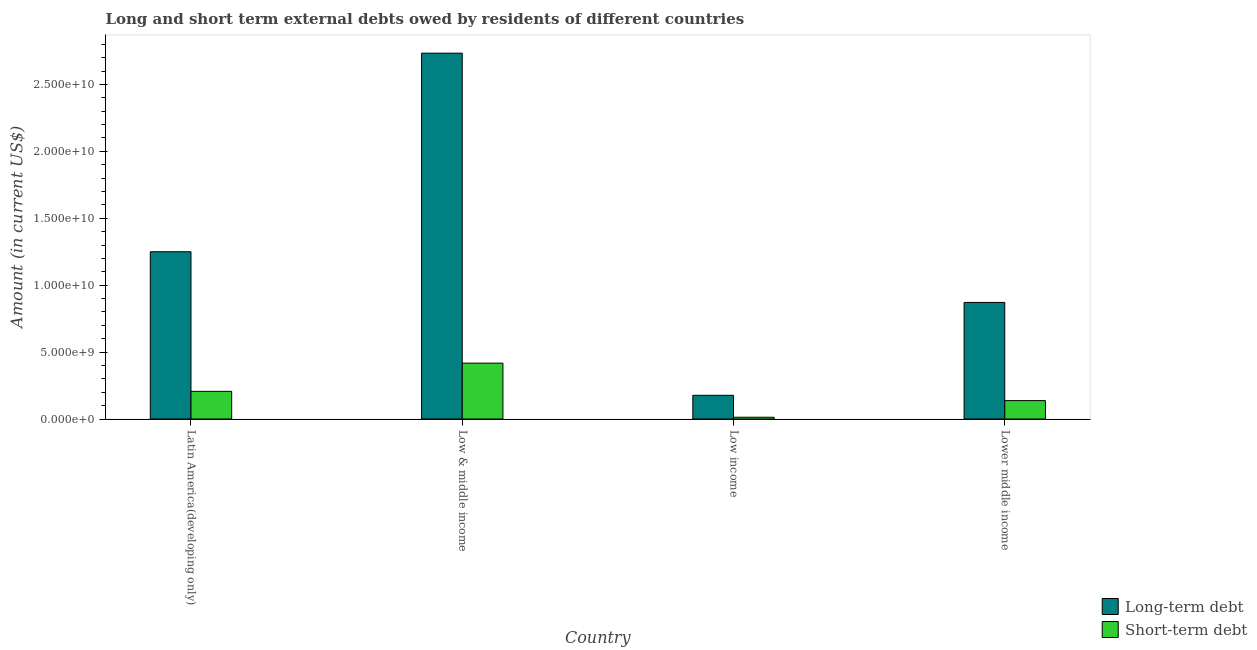How many different coloured bars are there?
Keep it short and to the point. 2. Are the number of bars per tick equal to the number of legend labels?
Make the answer very short. Yes. How many bars are there on the 3rd tick from the left?
Your response must be concise. 2. How many bars are there on the 3rd tick from the right?
Your answer should be very brief. 2. What is the label of the 2nd group of bars from the left?
Keep it short and to the point. Low & middle income. What is the short-term debts owed by residents in Lower middle income?
Offer a very short reply. 1.37e+09. Across all countries, what is the maximum long-term debts owed by residents?
Provide a short and direct response. 2.73e+1. Across all countries, what is the minimum short-term debts owed by residents?
Offer a very short reply. 1.32e+08. In which country was the long-term debts owed by residents maximum?
Make the answer very short. Low & middle income. In which country was the long-term debts owed by residents minimum?
Your response must be concise. Low income. What is the total short-term debts owed by residents in the graph?
Give a very brief answer. 7.75e+09. What is the difference between the long-term debts owed by residents in Latin America(developing only) and that in Lower middle income?
Provide a succinct answer. 3.79e+09. What is the difference between the short-term debts owed by residents in Lower middle income and the long-term debts owed by residents in Low income?
Your answer should be compact. -3.97e+08. What is the average long-term debts owed by residents per country?
Provide a short and direct response. 1.26e+1. What is the difference between the long-term debts owed by residents and short-term debts owed by residents in Lower middle income?
Make the answer very short. 7.34e+09. What is the ratio of the long-term debts owed by residents in Latin America(developing only) to that in Low income?
Offer a very short reply. 7.06. Is the difference between the short-term debts owed by residents in Low & middle income and Lower middle income greater than the difference between the long-term debts owed by residents in Low & middle income and Lower middle income?
Ensure brevity in your answer.  No. What is the difference between the highest and the second highest long-term debts owed by residents?
Give a very brief answer. 1.48e+1. What is the difference between the highest and the lowest short-term debts owed by residents?
Provide a short and direct response. 4.04e+09. What does the 1st bar from the left in Low income represents?
Your response must be concise. Long-term debt. What does the 1st bar from the right in Low income represents?
Make the answer very short. Short-term debt. How many bars are there?
Your response must be concise. 8. Are all the bars in the graph horizontal?
Offer a terse response. No. What is the difference between two consecutive major ticks on the Y-axis?
Your answer should be very brief. 5.00e+09. Are the values on the major ticks of Y-axis written in scientific E-notation?
Offer a terse response. Yes. Does the graph contain grids?
Offer a very short reply. No. Where does the legend appear in the graph?
Your response must be concise. Bottom right. How many legend labels are there?
Offer a terse response. 2. What is the title of the graph?
Give a very brief answer. Long and short term external debts owed by residents of different countries. What is the label or title of the Y-axis?
Offer a very short reply. Amount (in current US$). What is the Amount (in current US$) of Long-term debt in Latin America(developing only)?
Give a very brief answer. 1.25e+1. What is the Amount (in current US$) of Short-term debt in Latin America(developing only)?
Provide a succinct answer. 2.07e+09. What is the Amount (in current US$) in Long-term debt in Low & middle income?
Your answer should be very brief. 2.73e+1. What is the Amount (in current US$) of Short-term debt in Low & middle income?
Offer a very short reply. 4.18e+09. What is the Amount (in current US$) of Long-term debt in Low income?
Offer a very short reply. 1.77e+09. What is the Amount (in current US$) of Short-term debt in Low income?
Your answer should be compact. 1.32e+08. What is the Amount (in current US$) in Long-term debt in Lower middle income?
Give a very brief answer. 8.71e+09. What is the Amount (in current US$) in Short-term debt in Lower middle income?
Offer a terse response. 1.37e+09. Across all countries, what is the maximum Amount (in current US$) in Long-term debt?
Your response must be concise. 2.73e+1. Across all countries, what is the maximum Amount (in current US$) in Short-term debt?
Offer a terse response. 4.18e+09. Across all countries, what is the minimum Amount (in current US$) of Long-term debt?
Provide a succinct answer. 1.77e+09. Across all countries, what is the minimum Amount (in current US$) in Short-term debt?
Offer a very short reply. 1.32e+08. What is the total Amount (in current US$) of Long-term debt in the graph?
Keep it short and to the point. 5.03e+1. What is the total Amount (in current US$) in Short-term debt in the graph?
Make the answer very short. 7.75e+09. What is the difference between the Amount (in current US$) of Long-term debt in Latin America(developing only) and that in Low & middle income?
Offer a very short reply. -1.48e+1. What is the difference between the Amount (in current US$) of Short-term debt in Latin America(developing only) and that in Low & middle income?
Your answer should be very brief. -2.11e+09. What is the difference between the Amount (in current US$) in Long-term debt in Latin America(developing only) and that in Low income?
Offer a very short reply. 1.07e+1. What is the difference between the Amount (in current US$) of Short-term debt in Latin America(developing only) and that in Low income?
Your response must be concise. 1.94e+09. What is the difference between the Amount (in current US$) of Long-term debt in Latin America(developing only) and that in Lower middle income?
Your answer should be compact. 3.79e+09. What is the difference between the Amount (in current US$) of Short-term debt in Latin America(developing only) and that in Lower middle income?
Ensure brevity in your answer.  6.94e+08. What is the difference between the Amount (in current US$) in Long-term debt in Low & middle income and that in Low income?
Offer a terse response. 2.56e+1. What is the difference between the Amount (in current US$) in Short-term debt in Low & middle income and that in Low income?
Make the answer very short. 4.04e+09. What is the difference between the Amount (in current US$) in Long-term debt in Low & middle income and that in Lower middle income?
Ensure brevity in your answer.  1.86e+1. What is the difference between the Amount (in current US$) in Short-term debt in Low & middle income and that in Lower middle income?
Offer a very short reply. 2.80e+09. What is the difference between the Amount (in current US$) of Long-term debt in Low income and that in Lower middle income?
Offer a very short reply. -6.94e+09. What is the difference between the Amount (in current US$) of Short-term debt in Low income and that in Lower middle income?
Provide a short and direct response. -1.24e+09. What is the difference between the Amount (in current US$) in Long-term debt in Latin America(developing only) and the Amount (in current US$) in Short-term debt in Low & middle income?
Offer a terse response. 8.32e+09. What is the difference between the Amount (in current US$) in Long-term debt in Latin America(developing only) and the Amount (in current US$) in Short-term debt in Low income?
Your answer should be very brief. 1.24e+1. What is the difference between the Amount (in current US$) of Long-term debt in Latin America(developing only) and the Amount (in current US$) of Short-term debt in Lower middle income?
Make the answer very short. 1.11e+1. What is the difference between the Amount (in current US$) in Long-term debt in Low & middle income and the Amount (in current US$) in Short-term debt in Low income?
Ensure brevity in your answer.  2.72e+1. What is the difference between the Amount (in current US$) of Long-term debt in Low & middle income and the Amount (in current US$) of Short-term debt in Lower middle income?
Make the answer very short. 2.60e+1. What is the difference between the Amount (in current US$) in Long-term debt in Low income and the Amount (in current US$) in Short-term debt in Lower middle income?
Make the answer very short. 3.97e+08. What is the average Amount (in current US$) in Long-term debt per country?
Keep it short and to the point. 1.26e+1. What is the average Amount (in current US$) of Short-term debt per country?
Your answer should be compact. 1.94e+09. What is the difference between the Amount (in current US$) in Long-term debt and Amount (in current US$) in Short-term debt in Latin America(developing only)?
Give a very brief answer. 1.04e+1. What is the difference between the Amount (in current US$) of Long-term debt and Amount (in current US$) of Short-term debt in Low & middle income?
Provide a short and direct response. 2.32e+1. What is the difference between the Amount (in current US$) of Long-term debt and Amount (in current US$) of Short-term debt in Low income?
Offer a very short reply. 1.64e+09. What is the difference between the Amount (in current US$) in Long-term debt and Amount (in current US$) in Short-term debt in Lower middle income?
Offer a very short reply. 7.34e+09. What is the ratio of the Amount (in current US$) in Long-term debt in Latin America(developing only) to that in Low & middle income?
Your answer should be compact. 0.46. What is the ratio of the Amount (in current US$) in Short-term debt in Latin America(developing only) to that in Low & middle income?
Provide a succinct answer. 0.5. What is the ratio of the Amount (in current US$) in Long-term debt in Latin America(developing only) to that in Low income?
Give a very brief answer. 7.06. What is the ratio of the Amount (in current US$) in Short-term debt in Latin America(developing only) to that in Low income?
Offer a terse response. 15.63. What is the ratio of the Amount (in current US$) in Long-term debt in Latin America(developing only) to that in Lower middle income?
Ensure brevity in your answer.  1.43. What is the ratio of the Amount (in current US$) of Short-term debt in Latin America(developing only) to that in Lower middle income?
Ensure brevity in your answer.  1.5. What is the ratio of the Amount (in current US$) of Long-term debt in Low & middle income to that in Low income?
Your answer should be compact. 15.43. What is the ratio of the Amount (in current US$) in Short-term debt in Low & middle income to that in Low income?
Your answer should be very brief. 31.55. What is the ratio of the Amount (in current US$) of Long-term debt in Low & middle income to that in Lower middle income?
Your response must be concise. 3.14. What is the ratio of the Amount (in current US$) of Short-term debt in Low & middle income to that in Lower middle income?
Make the answer very short. 3.04. What is the ratio of the Amount (in current US$) of Long-term debt in Low income to that in Lower middle income?
Give a very brief answer. 0.2. What is the ratio of the Amount (in current US$) of Short-term debt in Low income to that in Lower middle income?
Give a very brief answer. 0.1. What is the difference between the highest and the second highest Amount (in current US$) of Long-term debt?
Your answer should be very brief. 1.48e+1. What is the difference between the highest and the second highest Amount (in current US$) of Short-term debt?
Provide a succinct answer. 2.11e+09. What is the difference between the highest and the lowest Amount (in current US$) in Long-term debt?
Provide a short and direct response. 2.56e+1. What is the difference between the highest and the lowest Amount (in current US$) in Short-term debt?
Provide a short and direct response. 4.04e+09. 